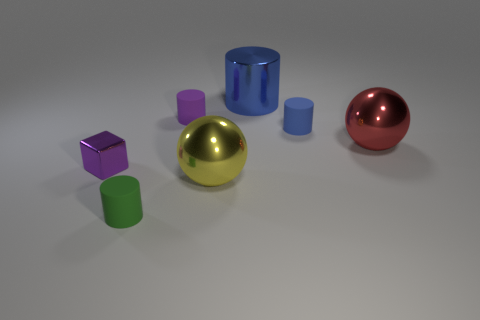There is a yellow thing that is made of the same material as the large blue cylinder; what size is it?
Provide a succinct answer. Large. There is a metallic thing that is both on the left side of the large cylinder and to the right of the purple metallic object; what is its color?
Keep it short and to the point. Yellow. How many yellow shiny objects are the same size as the purple cylinder?
Keep it short and to the point. 0. What size is the cylinder that is the same color as the cube?
Your answer should be very brief. Small. There is a metal thing that is both on the right side of the small purple block and to the left of the big cylinder; what is its size?
Your answer should be very brief. Large. There is a small purple thing that is right of the cylinder that is to the left of the tiny purple matte thing; what number of tiny things are on the right side of it?
Make the answer very short. 1. Is there another small metallic cube that has the same color as the tiny cube?
Your answer should be very brief. No. The metal cylinder that is the same size as the yellow sphere is what color?
Your response must be concise. Blue. There is a big thing in front of the large metallic ball behind the shiny thing in front of the purple metallic block; what is its shape?
Provide a short and direct response. Sphere. There is a small rubber object that is in front of the small purple block; how many tiny green cylinders are behind it?
Provide a succinct answer. 0. 